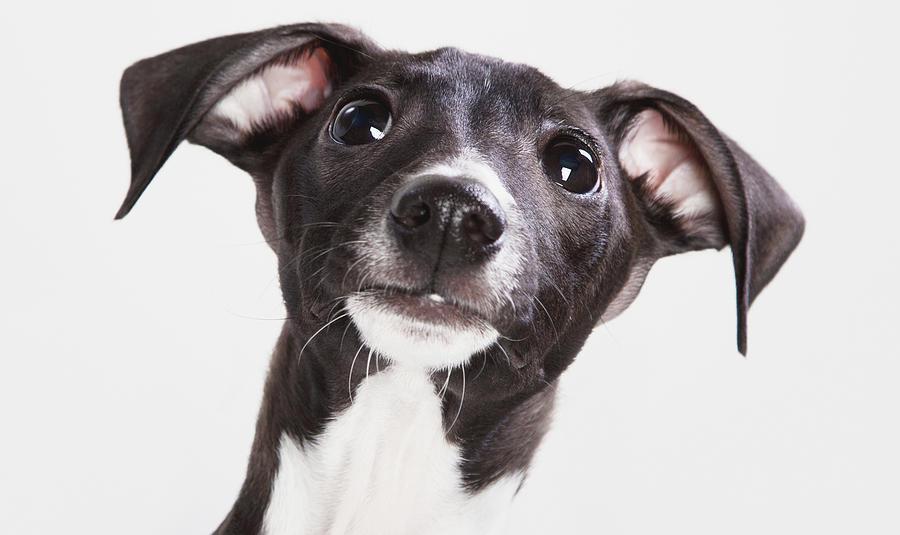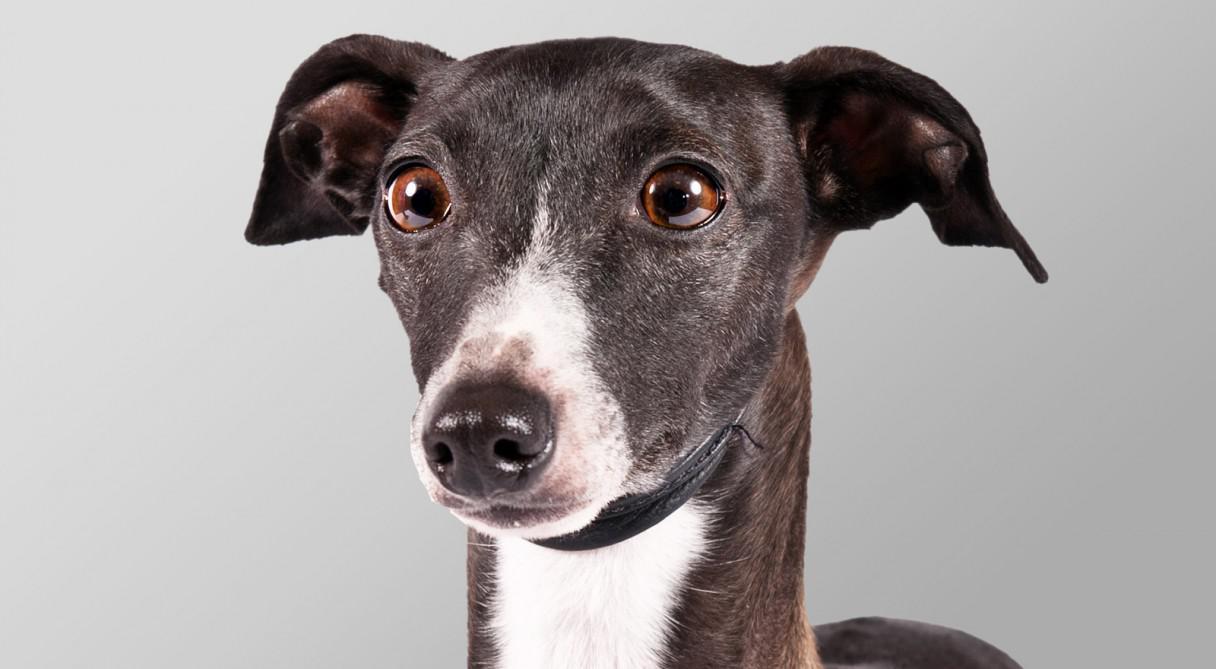The first image is the image on the left, the second image is the image on the right. Considering the images on both sides, is "Both of the images show dogs that look like puppies." valid? Answer yes or no. No. 